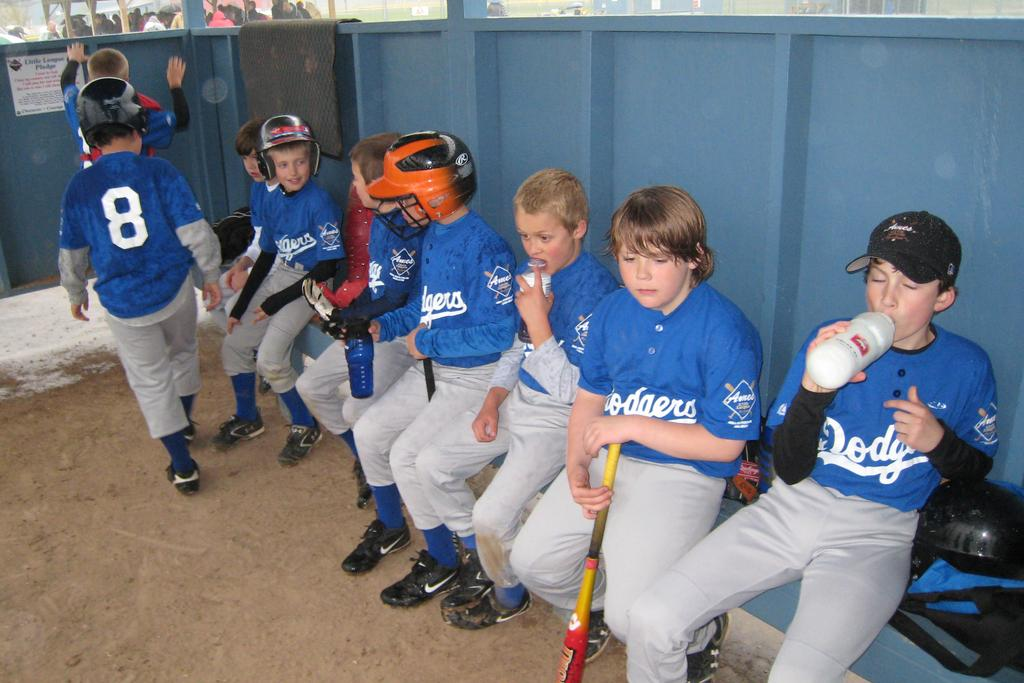Provide a one-sentence caption for the provided image. boys in dodgers uniforms sit in their dugout and there is a little league pledge on the wall. 